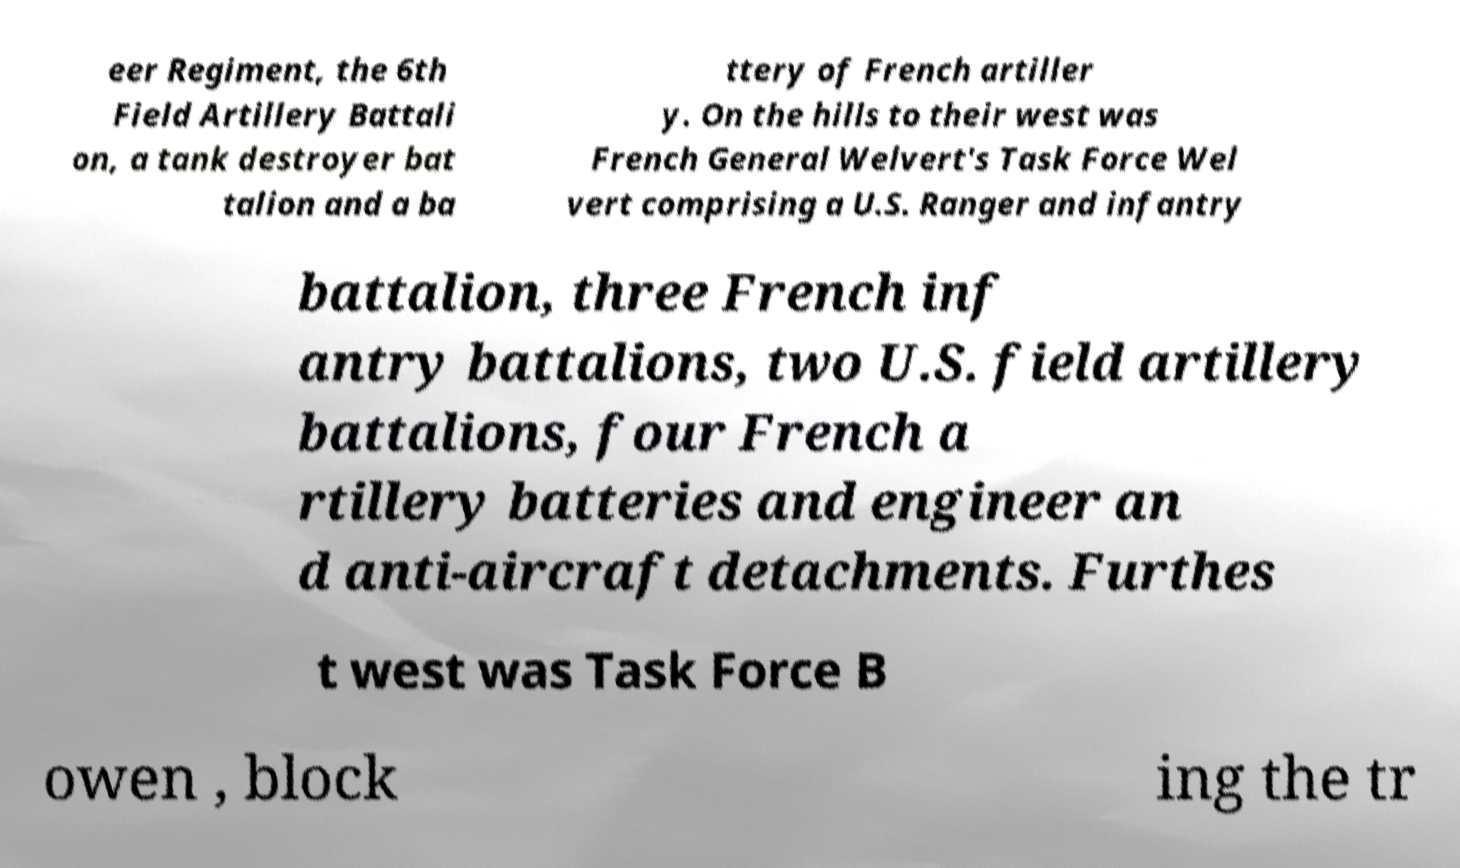Could you extract and type out the text from this image? eer Regiment, the 6th Field Artillery Battali on, a tank destroyer bat talion and a ba ttery of French artiller y. On the hills to their west was French General Welvert's Task Force Wel vert comprising a U.S. Ranger and infantry battalion, three French inf antry battalions, two U.S. field artillery battalions, four French a rtillery batteries and engineer an d anti-aircraft detachments. Furthes t west was Task Force B owen , block ing the tr 